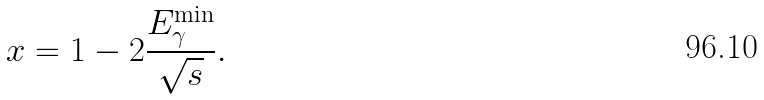Convert formula to latex. <formula><loc_0><loc_0><loc_500><loc_500>x = 1 - 2 \frac { E _ { \gamma } ^ { \min } } { \sqrt { s } } .</formula> 